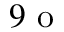<formula> <loc_0><loc_0><loc_500><loc_500>9 o</formula> 